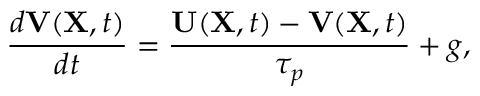<formula> <loc_0><loc_0><loc_500><loc_500>\frac { d { V } ( { X } , t ) } { d t } = \frac { { U } ( { X } , t ) - { V } ( { X } , t ) } { \tau _ { p } } + g ,</formula> 